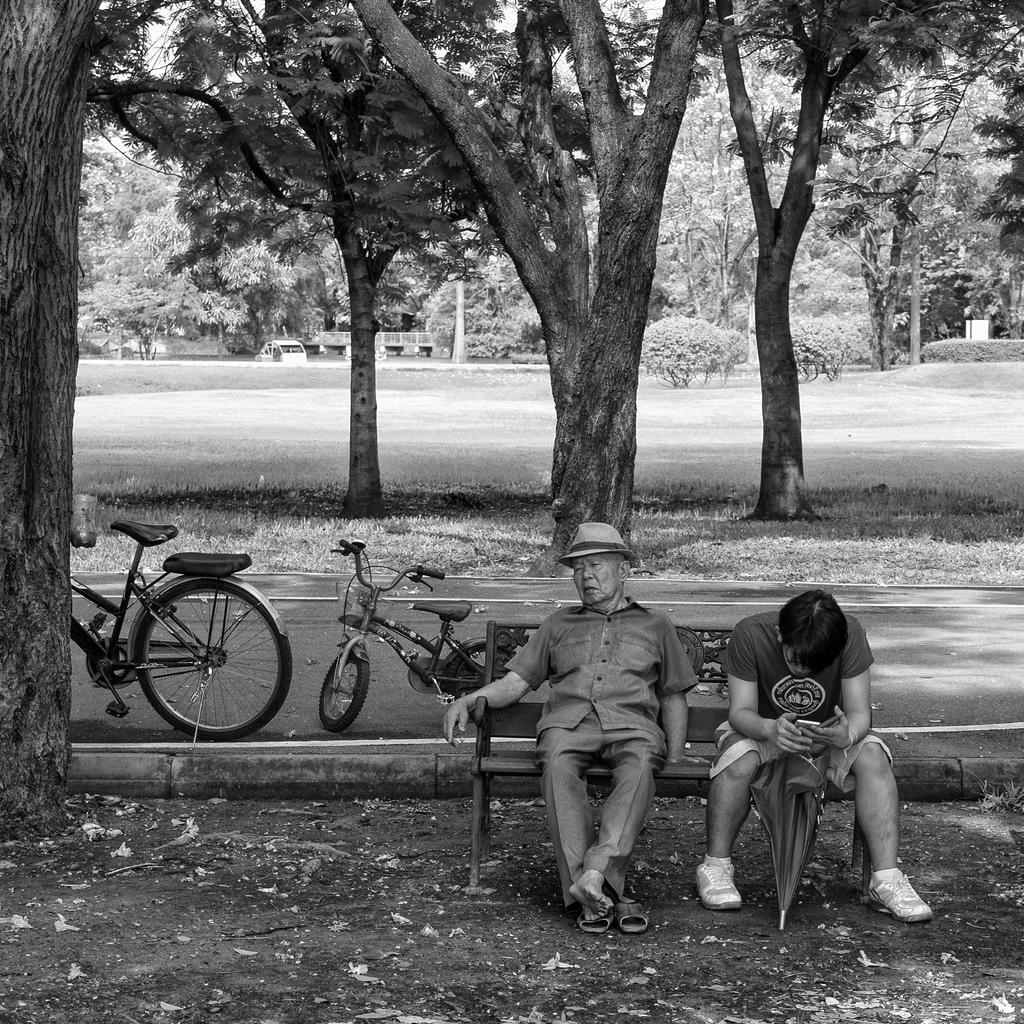In one or two sentences, can you explain what this image depicts? In the center of the image we can see two people sitting on the bench. On the left there are bicycles on the road. In the background there are trees, bushes and a car. 